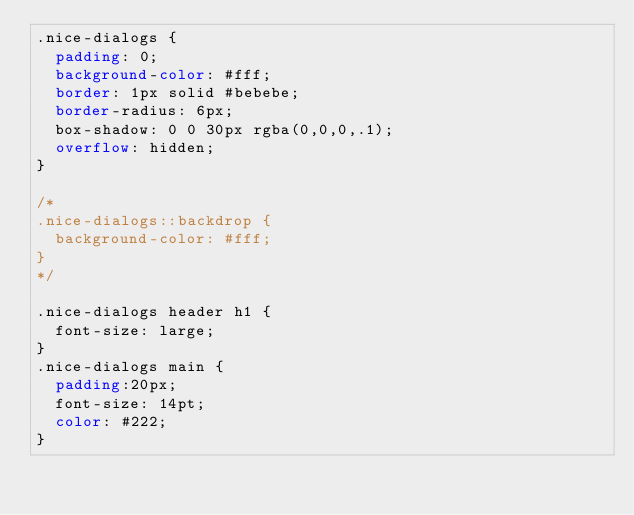Convert code to text. <code><loc_0><loc_0><loc_500><loc_500><_CSS_>.nice-dialogs {
  padding: 0;
  background-color: #fff;
  border: 1px solid #bebebe;
  border-radius: 6px;
  box-shadow: 0 0 30px rgba(0,0,0,.1);
  overflow: hidden;
}

/*
.nice-dialogs::backdrop {
  background-color: #fff;
}
*/

.nice-dialogs header h1 {
  font-size: large;
}
.nice-dialogs main {
  padding:20px;
  font-size: 14pt;
  color: #222;
}
</code> 